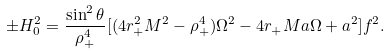Convert formula to latex. <formula><loc_0><loc_0><loc_500><loc_500>\pm H _ { 0 } ^ { 2 } = \frac { \sin ^ { 2 } \theta } { \rho _ { + } ^ { 4 } } [ ( 4 r _ { + } ^ { 2 } M ^ { 2 } - \rho _ { + } ^ { 4 } ) \Omega ^ { 2 } - 4 r _ { + } M a \Omega + a ^ { 2 } ] f ^ { 2 } .</formula> 